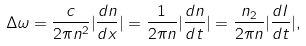Convert formula to latex. <formula><loc_0><loc_0><loc_500><loc_500>\Delta \omega = \frac { c } { 2 \pi n ^ { 2 } } | \frac { d n } { d x } | = \frac { 1 } { 2 \pi n } | \frac { d n } { d t } | = \frac { n _ { 2 } } { 2 \pi n } | \frac { d I } { d t } | ,</formula> 